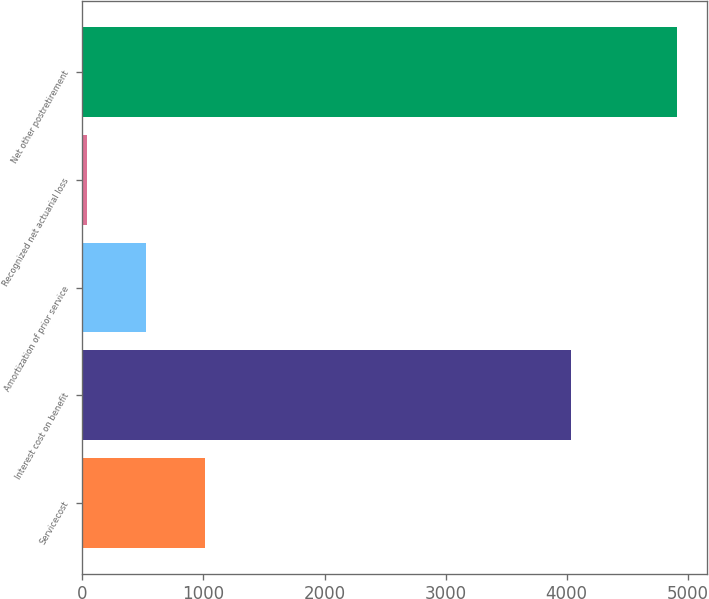<chart> <loc_0><loc_0><loc_500><loc_500><bar_chart><fcel>Servicecost<fcel>Interest cost on benefit<fcel>Amortization of prior service<fcel>Recognized net actuarial loss<fcel>Net other postretirement<nl><fcel>1015.4<fcel>4033<fcel>528.7<fcel>42<fcel>4909<nl></chart> 